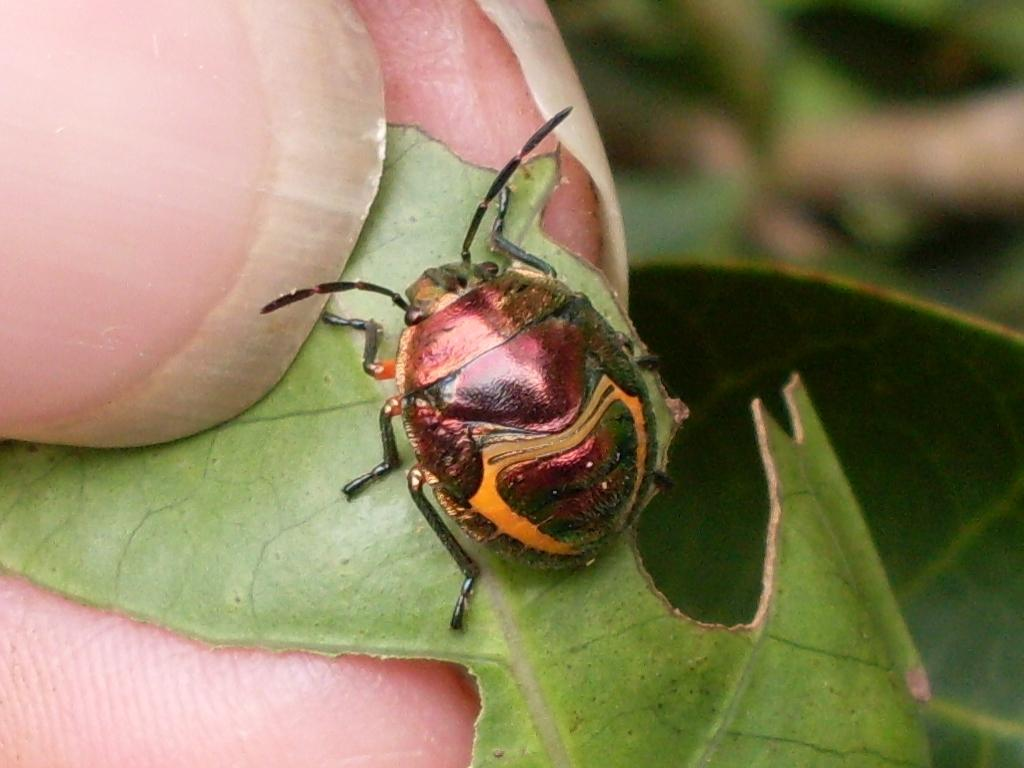What is the main subject of the image? The main subject of the image is an insect on a leaf. Can you describe the setting of the image? There are human fingers visible in the background of the image. What type of mouth does the insect have in the image? There is no indication of the insect's mouth in the image, as it is not visible. Is there any water visible in the image? There is no water visible in the image. 